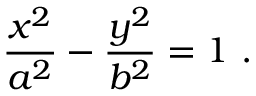<formula> <loc_0><loc_0><loc_500><loc_500>{ \frac { x ^ { 2 } } { a ^ { 2 } } } - { \frac { y ^ { 2 } } { b ^ { 2 } } } = 1 \ .</formula> 